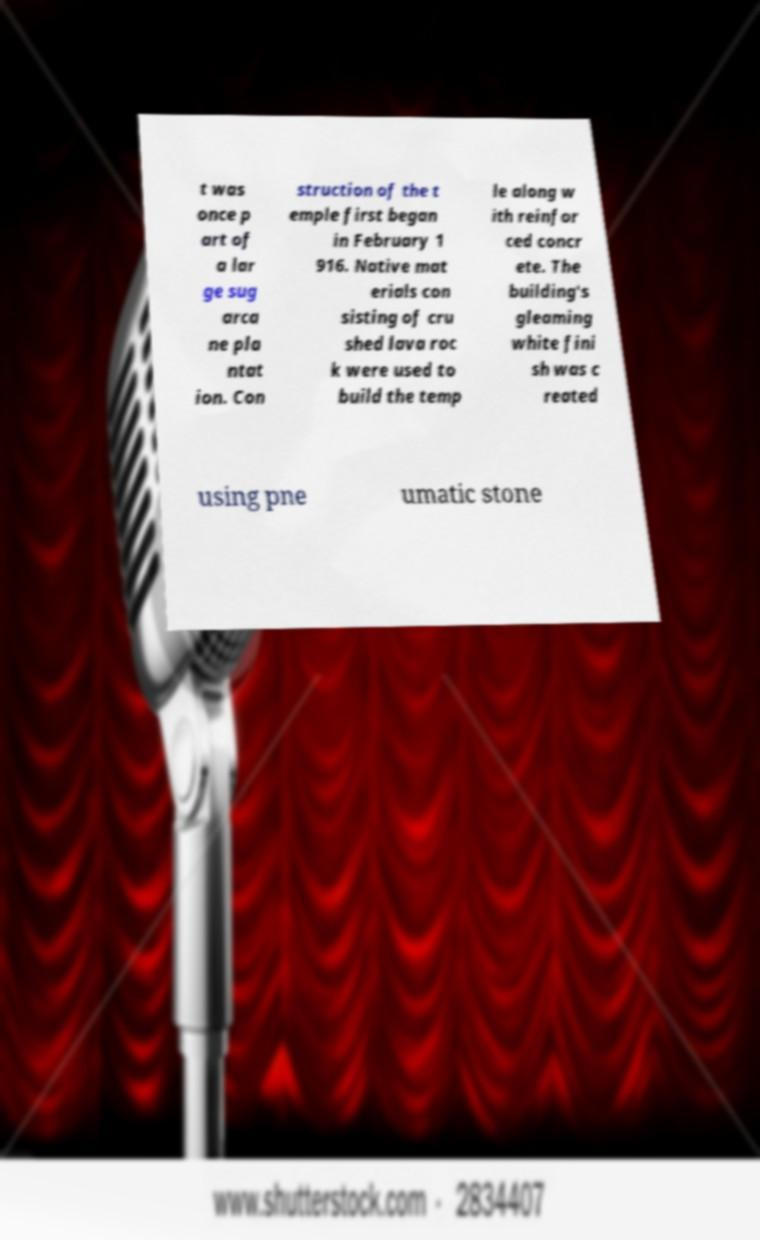There's text embedded in this image that I need extracted. Can you transcribe it verbatim? t was once p art of a lar ge sug arca ne pla ntat ion. Con struction of the t emple first began in February 1 916. Native mat erials con sisting of cru shed lava roc k were used to build the temp le along w ith reinfor ced concr ete. The building's gleaming white fini sh was c reated using pne umatic stone 